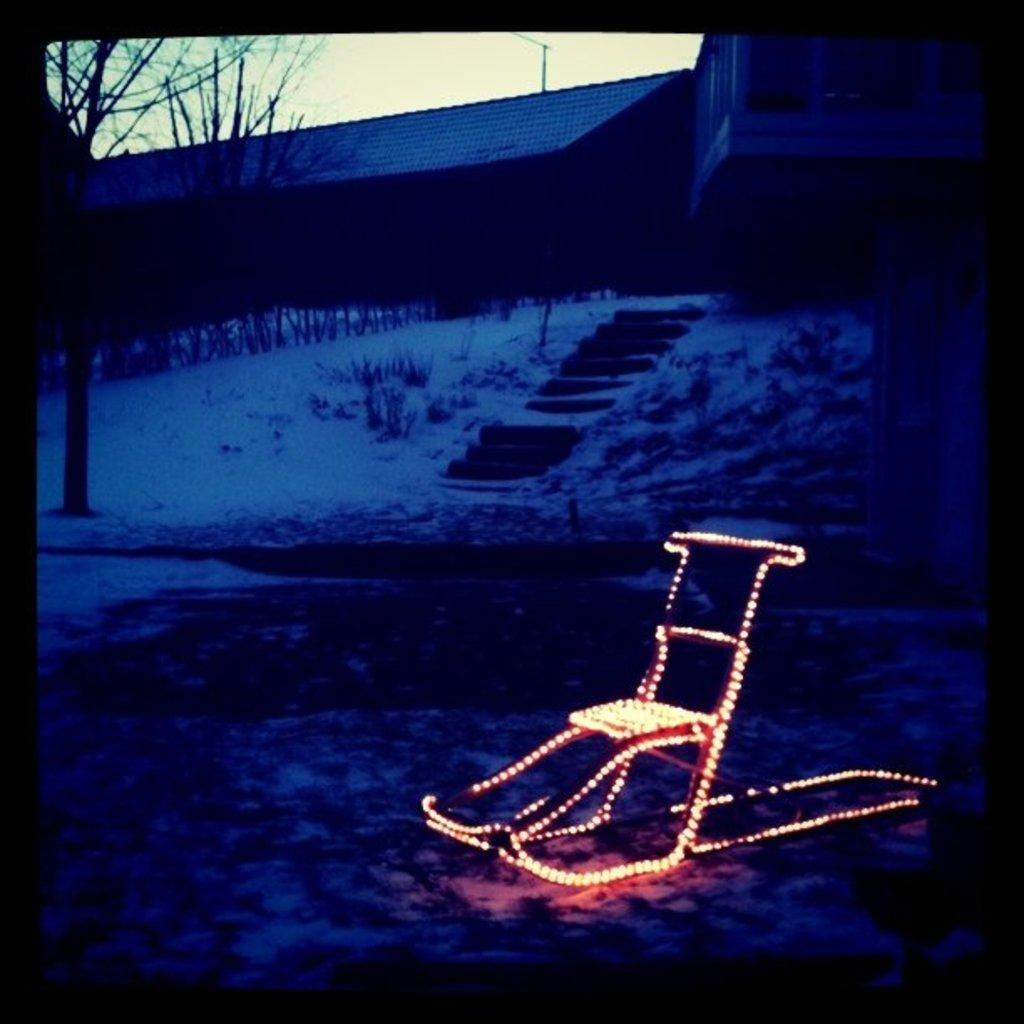What is the main object in the image with lights on it? There is a chair with lights in the image. Where is the chair located? The chair is on the snow. What type of structures can be seen in the image? There are houses in the image. What other natural elements are present in the image? There are trees and plants in the image. Are there any architectural features visible in the image? Yes, there are steps in the image. What can be seen in the background of the image? The sky is visible in the background of the image. What type of stew is being served in the image? There is no stew present in the image; it features a chair with lights on it, located on the snow, with houses, trees, plants, steps, and a visible sky in the background. 